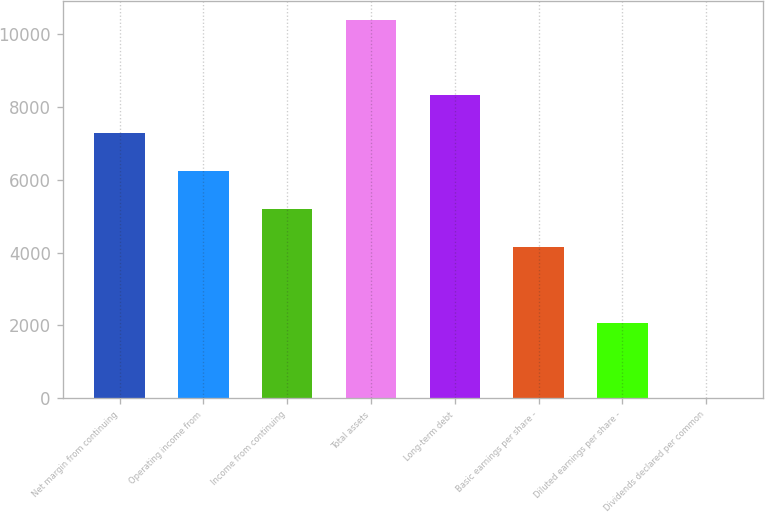Convert chart. <chart><loc_0><loc_0><loc_500><loc_500><bar_chart><fcel>Net margin from continuing<fcel>Operating income from<fcel>Income from continuing<fcel>Total assets<fcel>Long-term debt<fcel>Basic earnings per share -<fcel>Diluted earnings per share -<fcel>Dividends declared per common<nl><fcel>7274.15<fcel>6235.16<fcel>5196.17<fcel>10391.1<fcel>8313.14<fcel>4157.18<fcel>2079.2<fcel>1.22<nl></chart> 